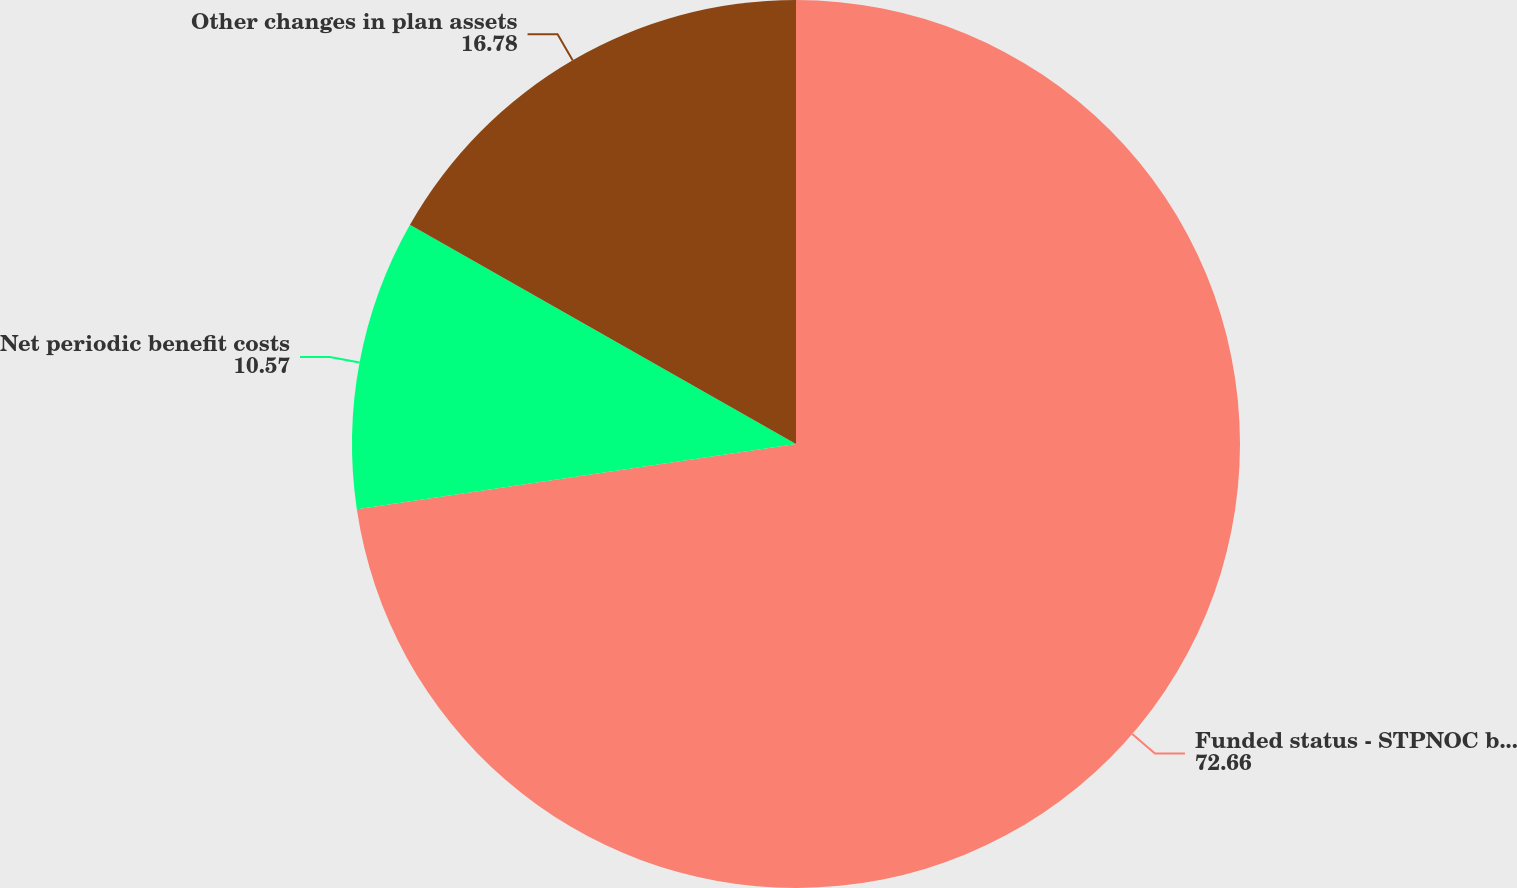Convert chart. <chart><loc_0><loc_0><loc_500><loc_500><pie_chart><fcel>Funded status - STPNOC benefit<fcel>Net periodic benefit costs<fcel>Other changes in plan assets<nl><fcel>72.66%<fcel>10.57%<fcel>16.78%<nl></chart> 